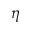Convert formula to latex. <formula><loc_0><loc_0><loc_500><loc_500>\eta</formula> 